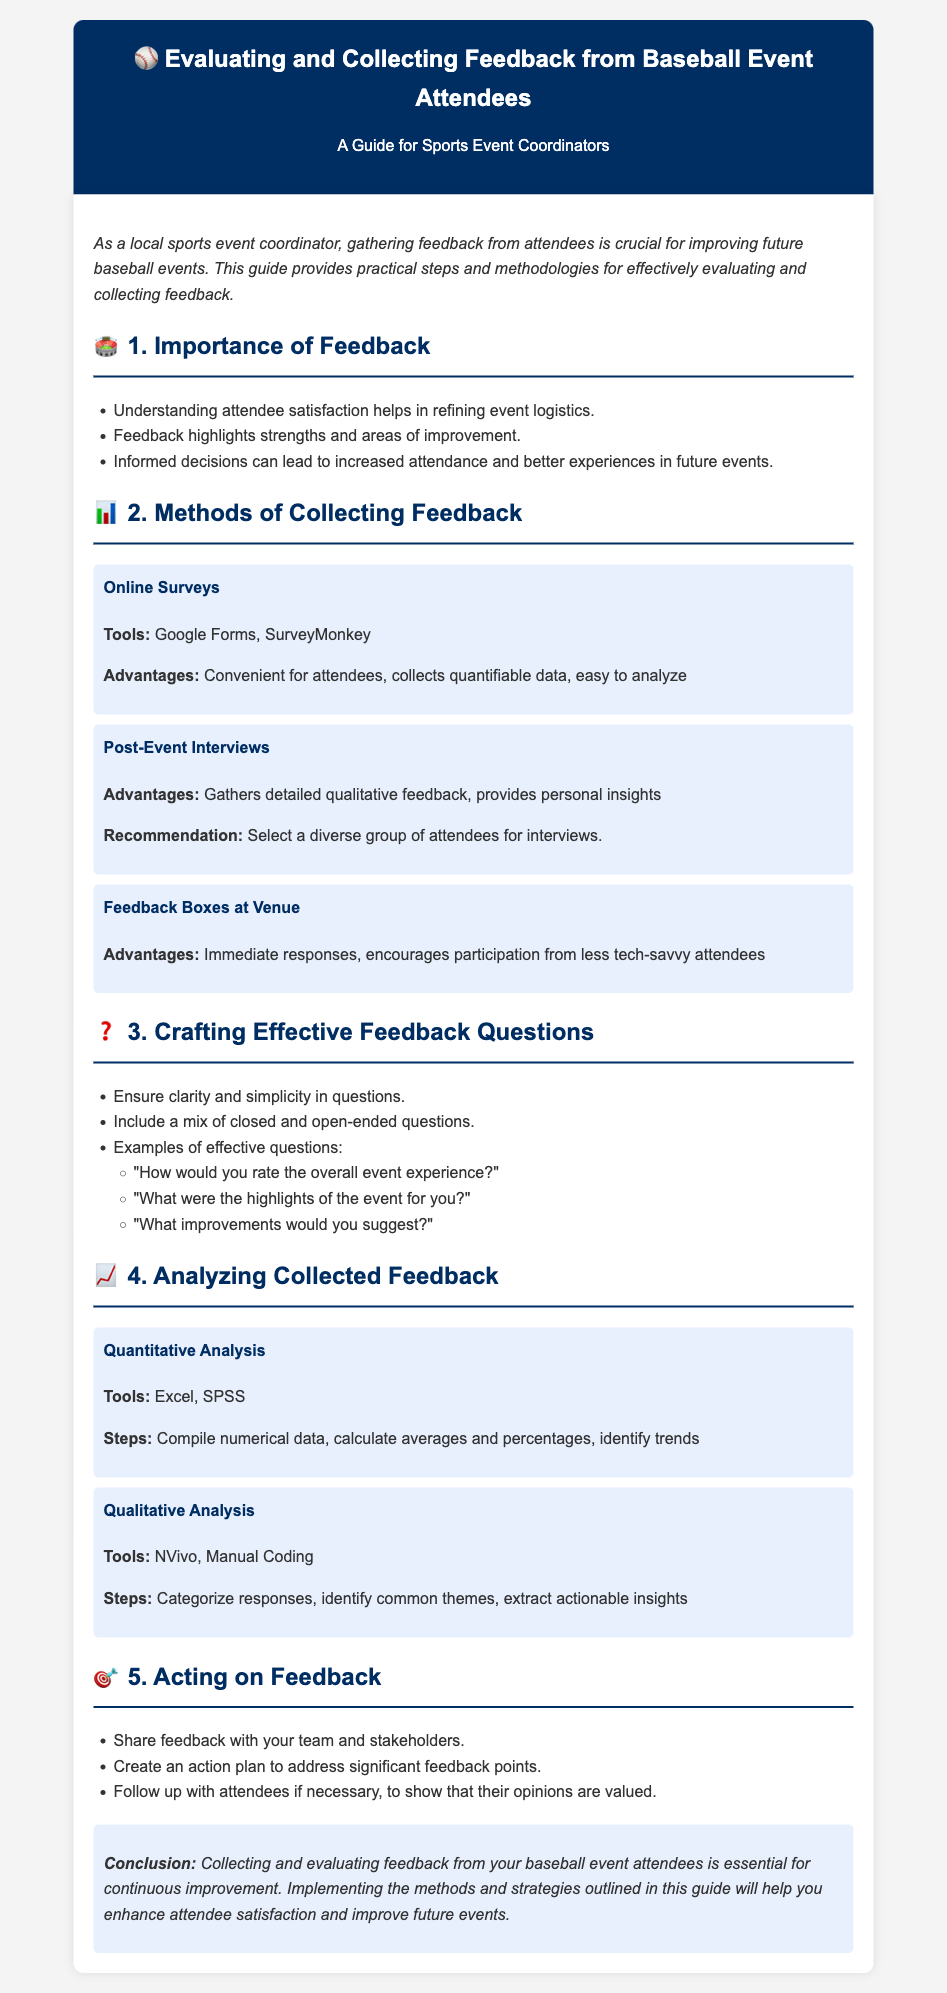What is the title of the document? The title is found in the header of the document, which indicates what the guide is about.
Answer: Evaluating and Collecting Feedback from Baseball Event Attendees What is one tool mentioned for online surveys? The tools are listed under the Online Surveys section, highlighting options available for feedback collection.
Answer: Google Forms What is an advantage of feedback boxes at the venue? The advantages are detailed under the respective section, explaining benefits of this feedback collection method.
Answer: Immediate responses What type of analysis uses tools like Excel? The document outlines different types of analyses performed on the collected feedback data.
Answer: Quantitative Analysis What should you include in your feedback questions? Recommendations for crafting effective questions are provided to enhance quality of feedback.
Answer: Closed and open-ended questions What is a common theme in analyzing qualitative feedback? The document discusses methods for qualitative analysis, highlighting key aspects to consider when interpreting responses.
Answer: Identify common themes What is the first step in acting on feedback? The guide lists a sequence of actions to take after analyzing gathered feedback to improve future events.
Answer: Share feedback with your team How many sections are in the document? The number of sections can be counted from the content structure provided in the document.
Answer: Five 